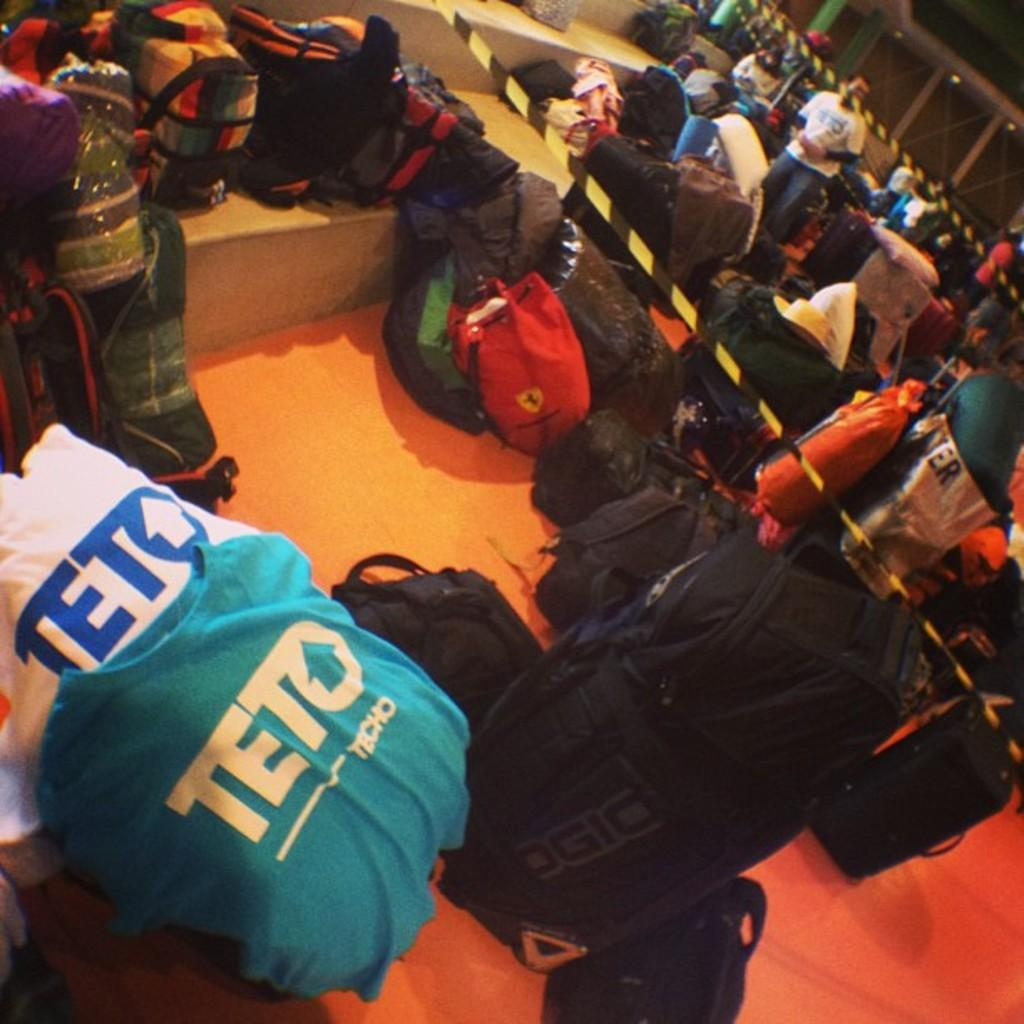<image>
Relay a brief, clear account of the picture shown. The Teto shirts are next to the baggage 